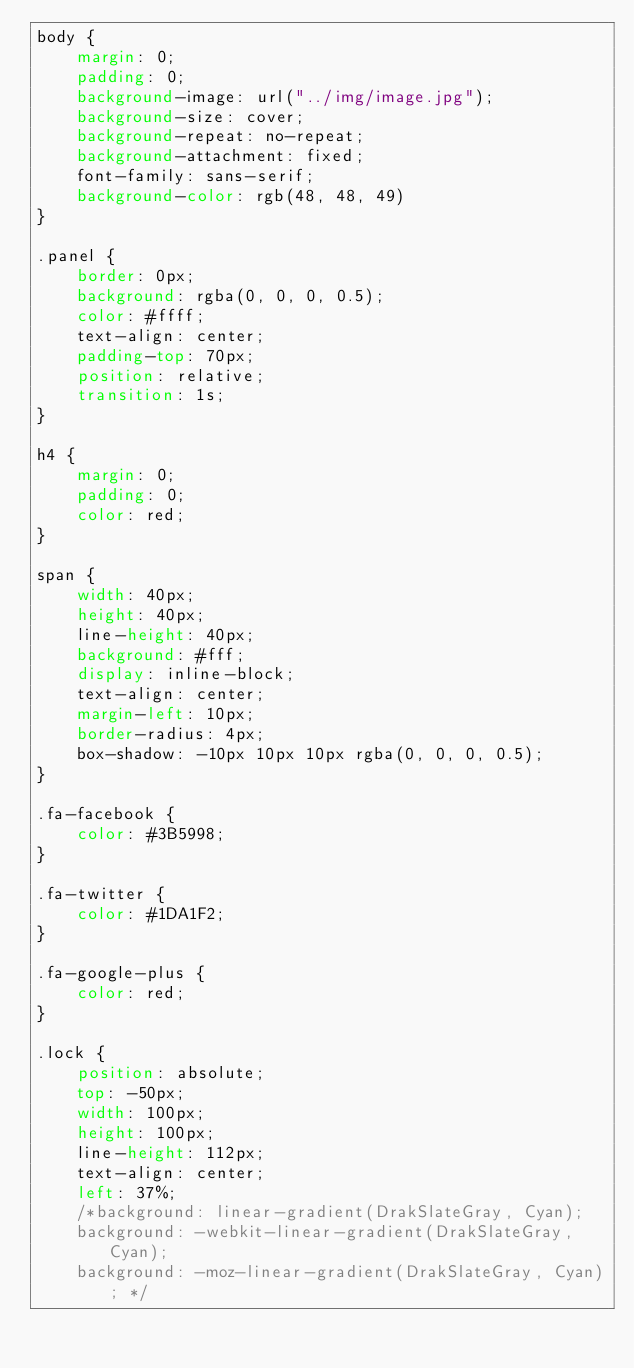<code> <loc_0><loc_0><loc_500><loc_500><_CSS_>body {
	margin: 0;
	padding: 0;
	background-image: url("../img/image.jpg");
	background-size: cover;
	background-repeat: no-repeat;
	background-attachment: fixed;
	font-family: sans-serif;
	background-color: rgb(48, 48, 49)
}

.panel {
	border: 0px;
	background: rgba(0, 0, 0, 0.5);
	color: #ffff;
	text-align: center;
	padding-top: 70px;
	position: relative;
	transition: 1s;
}

h4 {
	margin: 0;
	padding: 0;
	color: red;
}

span {
	width: 40px;
	height: 40px;
	line-height: 40px;
	background: #fff;
	display: inline-block;
	text-align: center;
	margin-left: 10px;
	border-radius: 4px;
	box-shadow: -10px 10px 10px rgba(0, 0, 0, 0.5);
}

.fa-facebook {
	color: #3B5998;
}

.fa-twitter {
	color: #1DA1F2;
}

.fa-google-plus {
	color: red;
}

.lock {
	position: absolute;
	top: -50px;
	width: 100px;
	height: 100px;
	line-height: 112px;
	text-align: center;
	left: 37%;
	/*background: linear-gradient(DrakSlateGray, Cyan);
	background: -webkit-linear-gradient(DrakSlateGray, Cyan);
	background: -moz-linear-gradient(DrakSlateGray, Cyan); */</code> 